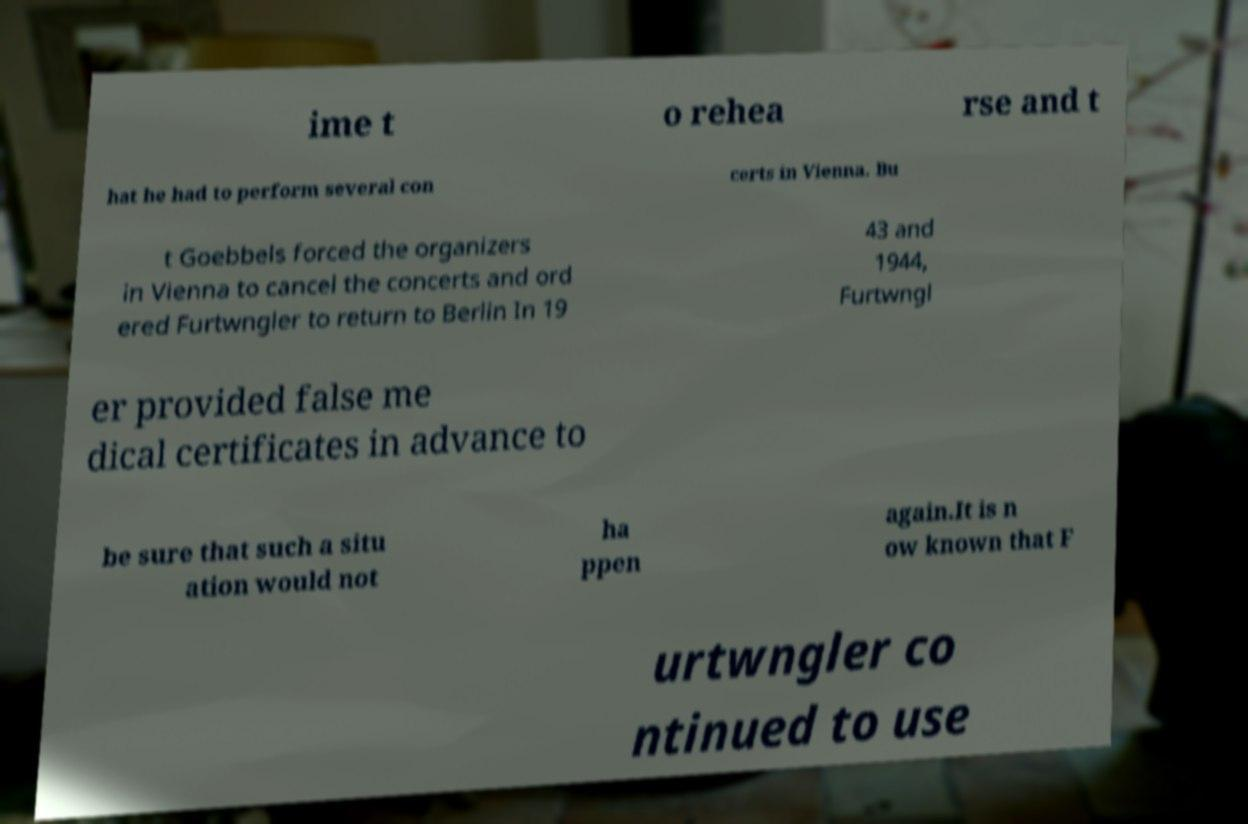For documentation purposes, I need the text within this image transcribed. Could you provide that? ime t o rehea rse and t hat he had to perform several con certs in Vienna. Bu t Goebbels forced the organizers in Vienna to cancel the concerts and ord ered Furtwngler to return to Berlin In 19 43 and 1944, Furtwngl er provided false me dical certificates in advance to be sure that such a situ ation would not ha ppen again.It is n ow known that F urtwngler co ntinued to use 